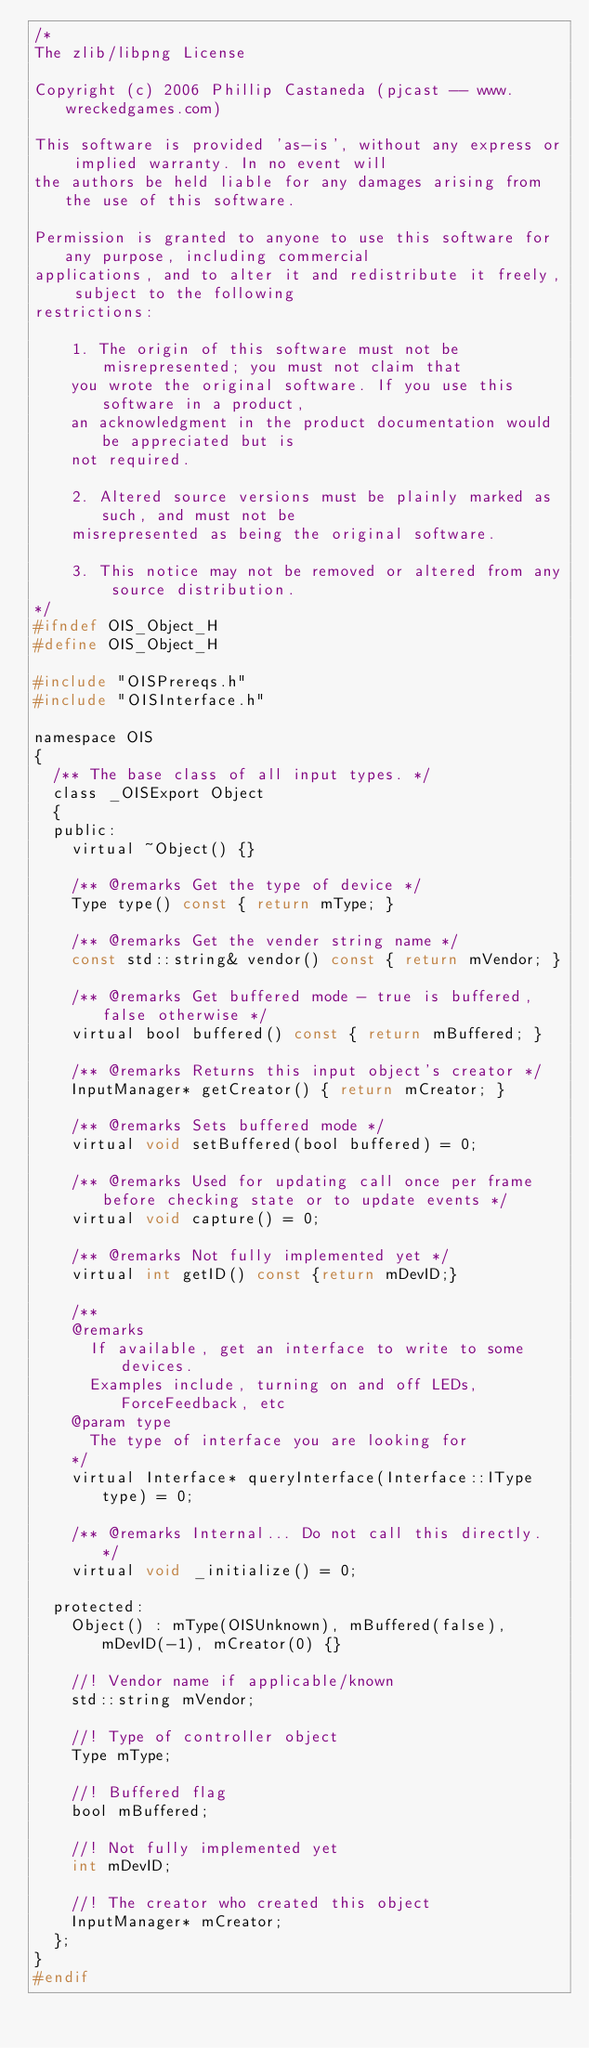Convert code to text. <code><loc_0><loc_0><loc_500><loc_500><_C_>/*
The zlib/libpng License

Copyright (c) 2006 Phillip Castaneda (pjcast -- www.wreckedgames.com)

This software is provided 'as-is', without any express or implied warranty. In no event will
the authors be held liable for any damages arising from the use of this software.

Permission is granted to anyone to use this software for any purpose, including commercial 
applications, and to alter it and redistribute it freely, subject to the following
restrictions:

    1. The origin of this software must not be misrepresented; you must not claim that 
		you wrote the original software. If you use this software in a product, 
		an acknowledgment in the product documentation would be appreciated but is 
		not required.

    2. Altered source versions must be plainly marked as such, and must not be 
		misrepresented as being the original software.

    3. This notice may not be removed or altered from any source distribution.
*/
#ifndef OIS_Object_H
#define OIS_Object_H

#include "OISPrereqs.h"
#include "OISInterface.h"

namespace OIS
{
	/**	The base class of all input types. */
	class _OISExport Object
	{
	public:
		virtual ~Object() {}

		/**	@remarks Get the type of device	*/
		Type type() const { return mType; }

		/**	@remarks Get the vender string name	*/
		const std::string& vendor() const { return mVendor; }

		/**	@remarks Get buffered mode - true is buffered, false otherwise */
		virtual bool buffered() const { return mBuffered; }

		/** @remarks Returns this input object's creator */
		InputManager* getCreator() { return mCreator; }

		/** @remarks Sets buffered mode	*/
		virtual void setBuffered(bool buffered) = 0;

		/**	@remarks Used for updating call once per frame before checking state or to update events */
		virtual void capture() = 0;

		/**	@remarks Not fully implemented yet */
		virtual int getID() const {return mDevID;}

		/**
		@remarks
			If available, get an interface to write to some devices.
			Examples include, turning on and off LEDs, ForceFeedback, etc
		@param type
			The type of interface you are looking for
		*/
		virtual Interface* queryInterface(Interface::IType type) = 0;

		/**	@remarks Internal... Do not call this directly. */
		virtual void _initialize() = 0;

	protected:
		Object() : mType(OISUnknown), mBuffered(false), mDevID(-1), mCreator(0) {}

		//! Vendor name if applicable/known
		std::string mVendor;

		//! Type of controller object
		Type mType;

		//! Buffered flag
		bool mBuffered;

		//! Not fully implemented yet
		int mDevID;

		//! The creator who created this object
		InputManager* mCreator;
	};
}
#endif
</code> 